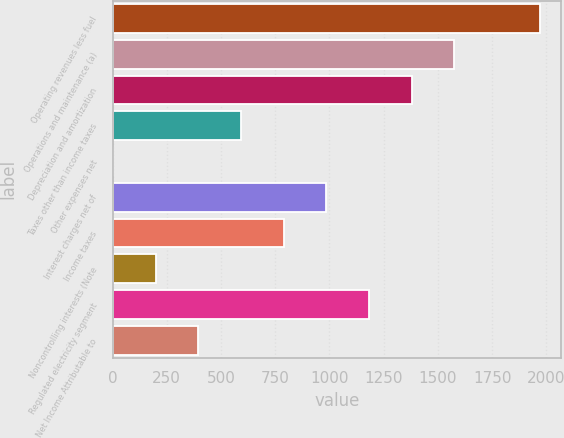<chart> <loc_0><loc_0><loc_500><loc_500><bar_chart><fcel>Operating revenues less fuel<fcel>Operations and maintenance (a)<fcel>Depreciation and amortization<fcel>Taxes other than income taxes<fcel>Other expenses net<fcel>Interest charges net of<fcel>Income taxes<fcel>Noncontrolling interests (Note<fcel>Regulated electricity segment<fcel>Net Income Attributable to<nl><fcel>1970<fcel>1576.4<fcel>1379.6<fcel>592.4<fcel>2<fcel>986<fcel>789.2<fcel>198.8<fcel>1182.8<fcel>395.6<nl></chart> 